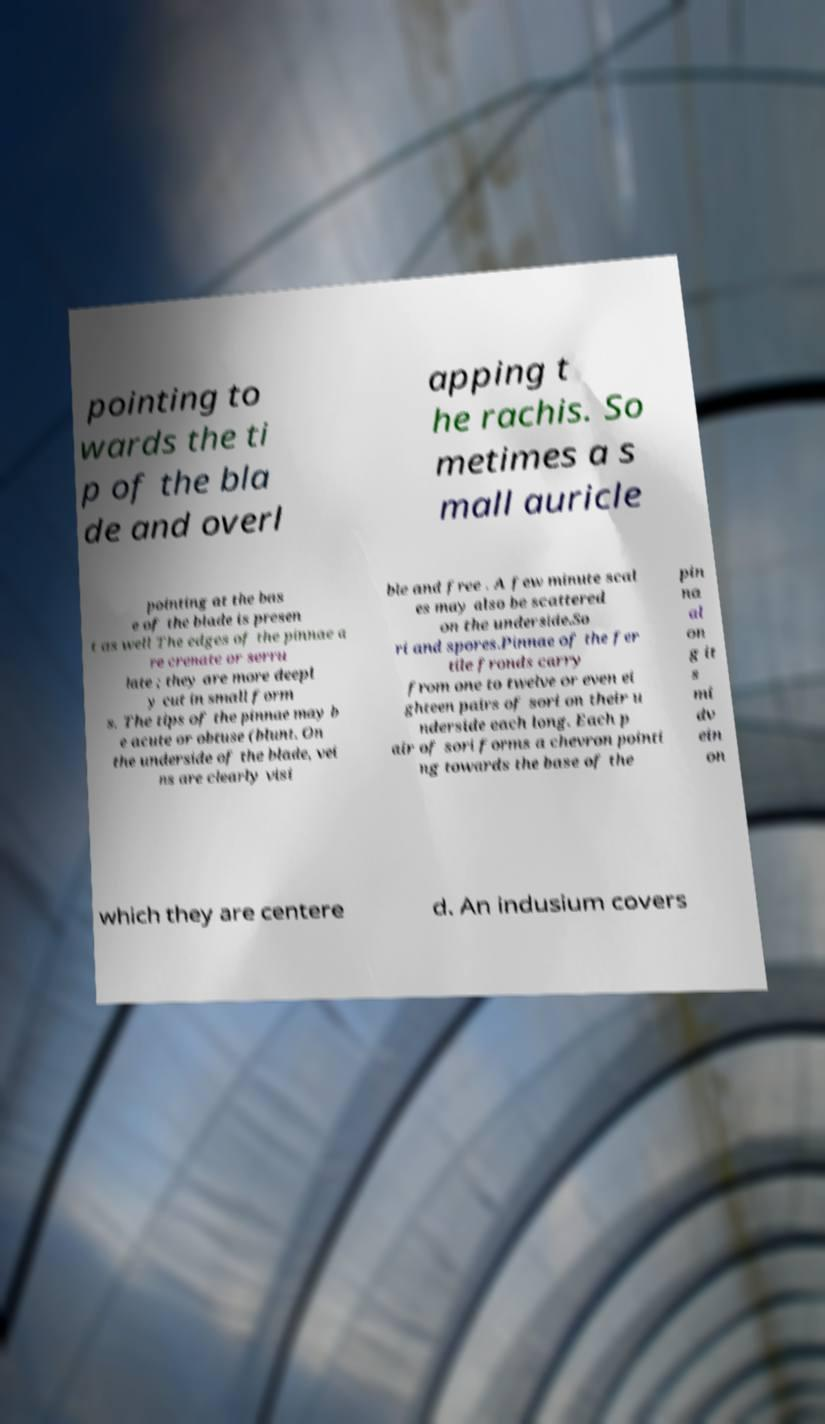Could you assist in decoding the text presented in this image and type it out clearly? pointing to wards the ti p of the bla de and overl apping t he rachis. So metimes a s mall auricle pointing at the bas e of the blade is presen t as well The edges of the pinnae a re crenate or serru late ; they are more deepl y cut in small form s. The tips of the pinnae may b e acute or obtuse (blunt. On the underside of the blade, vei ns are clearly visi ble and free . A few minute scal es may also be scattered on the underside.So ri and spores.Pinnae of the fer tile fronds carry from one to twelve or even ei ghteen pairs of sori on their u nderside each long. Each p air of sori forms a chevron pointi ng towards the base of the pin na al on g it s mi dv ein on which they are centere d. An indusium covers 